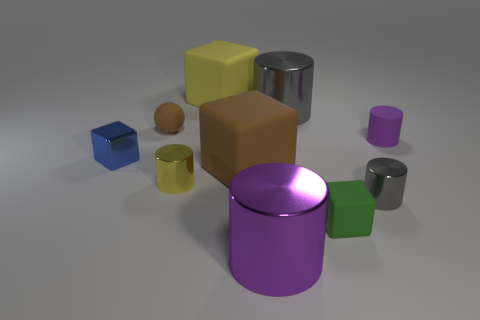Is there anything else that has the same shape as the large yellow thing?
Offer a very short reply. Yes. Do the yellow rubber object and the small brown object have the same shape?
Provide a succinct answer. No. Is there any other thing that has the same material as the large yellow thing?
Provide a succinct answer. Yes. What size is the rubber ball?
Your answer should be compact. Small. The small matte thing that is both on the right side of the yellow matte object and behind the tiny green matte cube is what color?
Your answer should be compact. Purple. Is the number of tiny blue matte cylinders greater than the number of tiny cylinders?
Your answer should be compact. No. How many objects are small green rubber blocks or small shiny things to the right of the tiny blue metal thing?
Your answer should be very brief. 3. Do the yellow rubber object and the green rubber thing have the same size?
Your response must be concise. No. There is a small brown ball; are there any yellow cylinders behind it?
Your response must be concise. No. There is a rubber block that is both behind the small yellow shiny cylinder and in front of the yellow block; what size is it?
Provide a succinct answer. Large. 